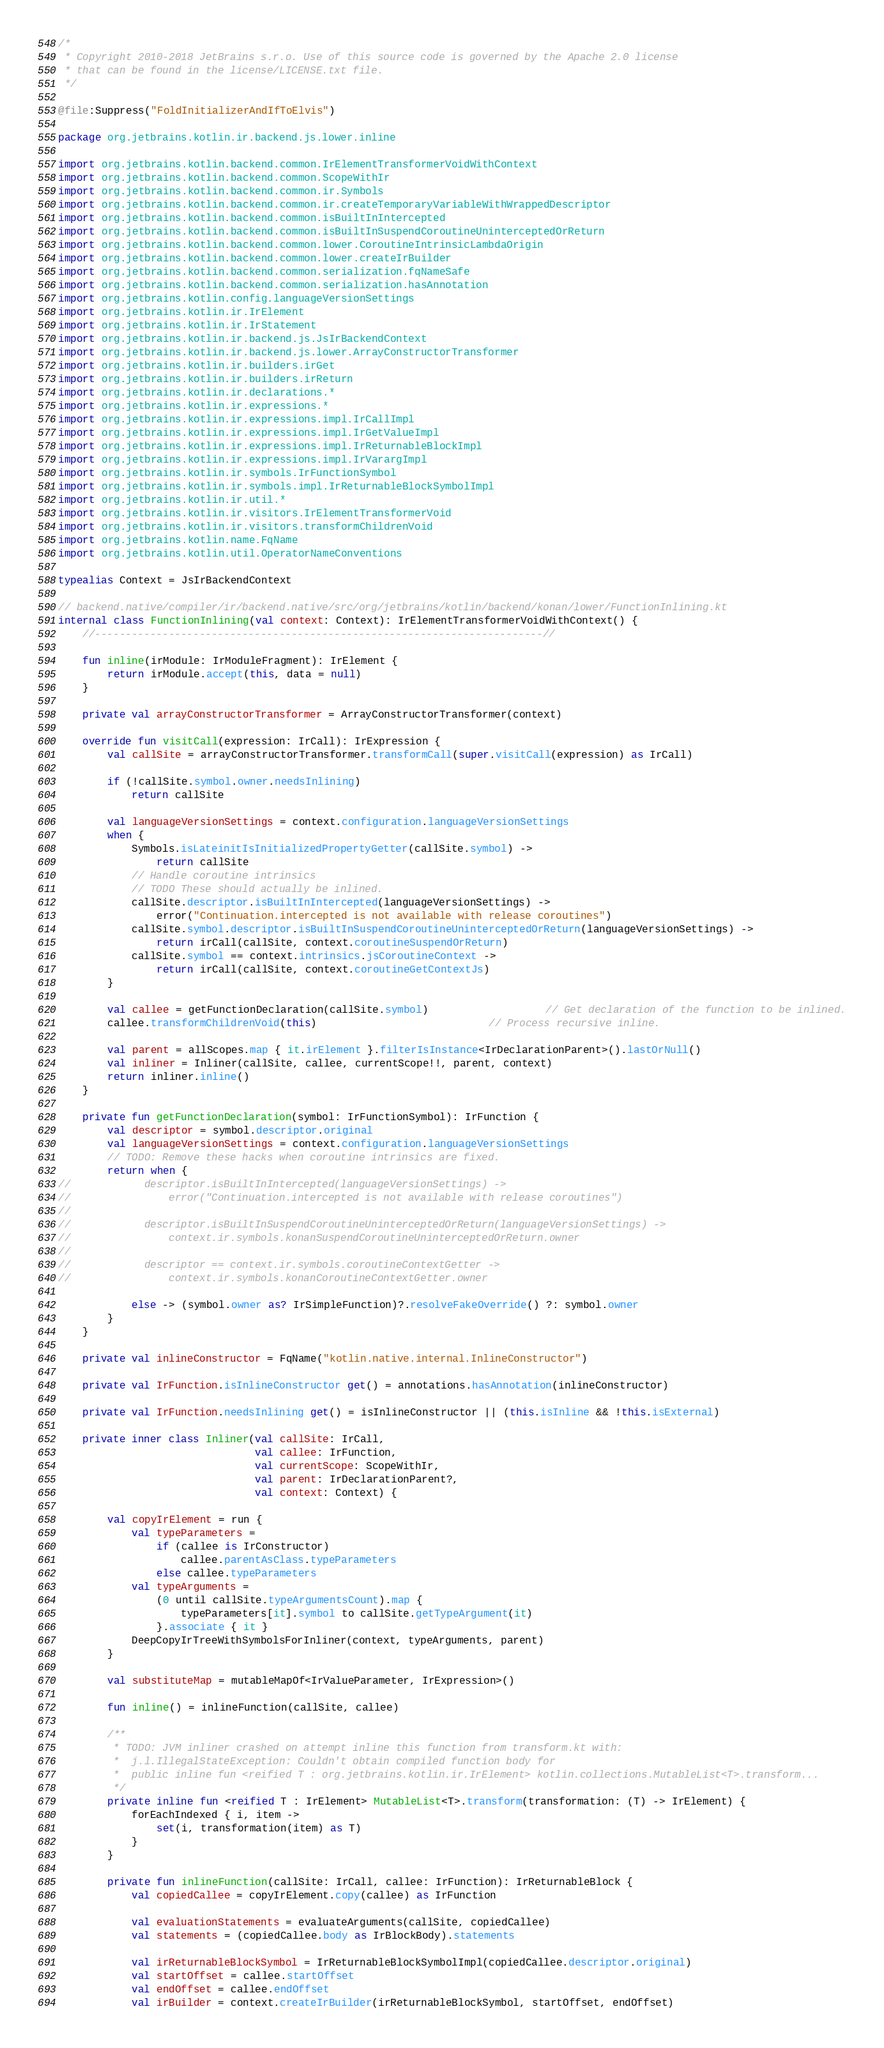Convert code to text. <code><loc_0><loc_0><loc_500><loc_500><_Kotlin_>/*
 * Copyright 2010-2018 JetBrains s.r.o. Use of this source code is governed by the Apache 2.0 license
 * that can be found in the license/LICENSE.txt file.
 */

@file:Suppress("FoldInitializerAndIfToElvis")

package org.jetbrains.kotlin.ir.backend.js.lower.inline

import org.jetbrains.kotlin.backend.common.IrElementTransformerVoidWithContext
import org.jetbrains.kotlin.backend.common.ScopeWithIr
import org.jetbrains.kotlin.backend.common.ir.Symbols
import org.jetbrains.kotlin.backend.common.ir.createTemporaryVariableWithWrappedDescriptor
import org.jetbrains.kotlin.backend.common.isBuiltInIntercepted
import org.jetbrains.kotlin.backend.common.isBuiltInSuspendCoroutineUninterceptedOrReturn
import org.jetbrains.kotlin.backend.common.lower.CoroutineIntrinsicLambdaOrigin
import org.jetbrains.kotlin.backend.common.lower.createIrBuilder
import org.jetbrains.kotlin.backend.common.serialization.fqNameSafe
import org.jetbrains.kotlin.backend.common.serialization.hasAnnotation
import org.jetbrains.kotlin.config.languageVersionSettings
import org.jetbrains.kotlin.ir.IrElement
import org.jetbrains.kotlin.ir.IrStatement
import org.jetbrains.kotlin.ir.backend.js.JsIrBackendContext
import org.jetbrains.kotlin.ir.backend.js.lower.ArrayConstructorTransformer
import org.jetbrains.kotlin.ir.builders.irGet
import org.jetbrains.kotlin.ir.builders.irReturn
import org.jetbrains.kotlin.ir.declarations.*
import org.jetbrains.kotlin.ir.expressions.*
import org.jetbrains.kotlin.ir.expressions.impl.IrCallImpl
import org.jetbrains.kotlin.ir.expressions.impl.IrGetValueImpl
import org.jetbrains.kotlin.ir.expressions.impl.IrReturnableBlockImpl
import org.jetbrains.kotlin.ir.expressions.impl.IrVarargImpl
import org.jetbrains.kotlin.ir.symbols.IrFunctionSymbol
import org.jetbrains.kotlin.ir.symbols.impl.IrReturnableBlockSymbolImpl
import org.jetbrains.kotlin.ir.util.*
import org.jetbrains.kotlin.ir.visitors.IrElementTransformerVoid
import org.jetbrains.kotlin.ir.visitors.transformChildrenVoid
import org.jetbrains.kotlin.name.FqName
import org.jetbrains.kotlin.util.OperatorNameConventions

typealias Context = JsIrBackendContext

// backend.native/compiler/ir/backend.native/src/org/jetbrains/kotlin/backend/konan/lower/FunctionInlining.kt
internal class FunctionInlining(val context: Context): IrElementTransformerVoidWithContext() {
    //-------------------------------------------------------------------------//

    fun inline(irModule: IrModuleFragment): IrElement {
        return irModule.accept(this, data = null)
    }

    private val arrayConstructorTransformer = ArrayConstructorTransformer(context)

    override fun visitCall(expression: IrCall): IrExpression {
        val callSite = arrayConstructorTransformer.transformCall(super.visitCall(expression) as IrCall)

        if (!callSite.symbol.owner.needsInlining)
            return callSite

        val languageVersionSettings = context.configuration.languageVersionSettings
        when {
            Symbols.isLateinitIsInitializedPropertyGetter(callSite.symbol) ->
                return callSite
            // Handle coroutine intrinsics
            // TODO These should actually be inlined.
            callSite.descriptor.isBuiltInIntercepted(languageVersionSettings) ->
                error("Continuation.intercepted is not available with release coroutines")
            callSite.symbol.descriptor.isBuiltInSuspendCoroutineUninterceptedOrReturn(languageVersionSettings) ->
                return irCall(callSite, context.coroutineSuspendOrReturn)
            callSite.symbol == context.intrinsics.jsCoroutineContext ->
                return irCall(callSite, context.coroutineGetContextJs)
        }

        val callee = getFunctionDeclaration(callSite.symbol)                   // Get declaration of the function to be inlined.
        callee.transformChildrenVoid(this)                            // Process recursive inline.

        val parent = allScopes.map { it.irElement }.filterIsInstance<IrDeclarationParent>().lastOrNull()
        val inliner = Inliner(callSite, callee, currentScope!!, parent, context)
        return inliner.inline()
    }

    private fun getFunctionDeclaration(symbol: IrFunctionSymbol): IrFunction {
        val descriptor = symbol.descriptor.original
        val languageVersionSettings = context.configuration.languageVersionSettings
        // TODO: Remove these hacks when coroutine intrinsics are fixed.
        return when {
//            descriptor.isBuiltInIntercepted(languageVersionSettings) ->
//                error("Continuation.intercepted is not available with release coroutines")
//
//            descriptor.isBuiltInSuspendCoroutineUninterceptedOrReturn(languageVersionSettings) ->
//                context.ir.symbols.konanSuspendCoroutineUninterceptedOrReturn.owner
//
//            descriptor == context.ir.symbols.coroutineContextGetter ->
//                context.ir.symbols.konanCoroutineContextGetter.owner

            else -> (symbol.owner as? IrSimpleFunction)?.resolveFakeOverride() ?: symbol.owner
        }
    }

    private val inlineConstructor = FqName("kotlin.native.internal.InlineConstructor")

    private val IrFunction.isInlineConstructor get() = annotations.hasAnnotation(inlineConstructor)

    private val IrFunction.needsInlining get() = isInlineConstructor || (this.isInline && !this.isExternal)

    private inner class Inliner(val callSite: IrCall,
                                val callee: IrFunction,
                                val currentScope: ScopeWithIr,
                                val parent: IrDeclarationParent?,
                                val context: Context) {

        val copyIrElement = run {
            val typeParameters =
                if (callee is IrConstructor)
                    callee.parentAsClass.typeParameters
                else callee.typeParameters
            val typeArguments =
                (0 until callSite.typeArgumentsCount).map {
                    typeParameters[it].symbol to callSite.getTypeArgument(it)
                }.associate { it }
            DeepCopyIrTreeWithSymbolsForInliner(context, typeArguments, parent)
        }

        val substituteMap = mutableMapOf<IrValueParameter, IrExpression>()

        fun inline() = inlineFunction(callSite, callee)

        /**
         * TODO: JVM inliner crashed on attempt inline this function from transform.kt with:
         *  j.l.IllegalStateException: Couldn't obtain compiled function body for
         *  public inline fun <reified T : org.jetbrains.kotlin.ir.IrElement> kotlin.collections.MutableList<T>.transform...
         */
        private inline fun <reified T : IrElement> MutableList<T>.transform(transformation: (T) -> IrElement) {
            forEachIndexed { i, item ->
                set(i, transformation(item) as T)
            }
        }

        private fun inlineFunction(callSite: IrCall, callee: IrFunction): IrReturnableBlock {
            val copiedCallee = copyIrElement.copy(callee) as IrFunction

            val evaluationStatements = evaluateArguments(callSite, copiedCallee)
            val statements = (copiedCallee.body as IrBlockBody).statements

            val irReturnableBlockSymbol = IrReturnableBlockSymbolImpl(copiedCallee.descriptor.original)
            val startOffset = callee.startOffset
            val endOffset = callee.endOffset
            val irBuilder = context.createIrBuilder(irReturnableBlockSymbol, startOffset, endOffset)
</code> 